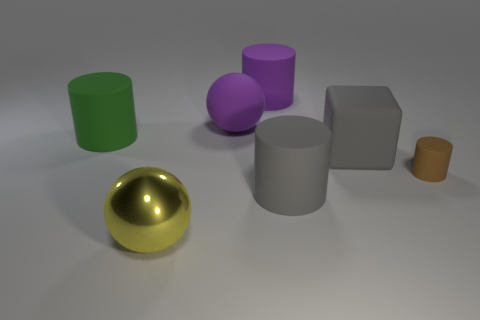Add 3 cylinders. How many objects exist? 10 Subtract all balls. How many objects are left? 5 Add 6 small objects. How many small objects exist? 7 Subtract 1 purple cylinders. How many objects are left? 6 Subtract all big gray rubber cylinders. Subtract all brown matte objects. How many objects are left? 5 Add 6 big green objects. How many big green objects are left? 7 